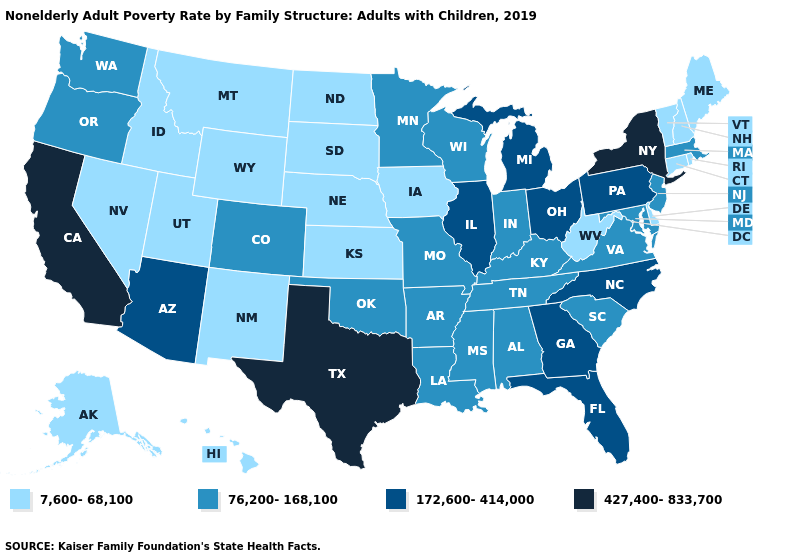What is the value of Alabama?
Be succinct. 76,200-168,100. Does Ohio have the same value as Pennsylvania?
Quick response, please. Yes. What is the lowest value in states that border Kentucky?
Be succinct. 7,600-68,100. What is the highest value in states that border New York?
Write a very short answer. 172,600-414,000. What is the value of Georgia?
Be succinct. 172,600-414,000. What is the value of Wyoming?
Concise answer only. 7,600-68,100. Among the states that border Kentucky , does West Virginia have the lowest value?
Write a very short answer. Yes. Name the states that have a value in the range 427,400-833,700?
Answer briefly. California, New York, Texas. How many symbols are there in the legend?
Write a very short answer. 4. Does Georgia have the highest value in the USA?
Concise answer only. No. Does the map have missing data?
Answer briefly. No. Does Pennsylvania have the lowest value in the Northeast?
Concise answer only. No. Which states have the highest value in the USA?
Concise answer only. California, New York, Texas. Among the states that border Virginia , does North Carolina have the highest value?
Quick response, please. Yes. Among the states that border Virginia , does West Virginia have the lowest value?
Quick response, please. Yes. 